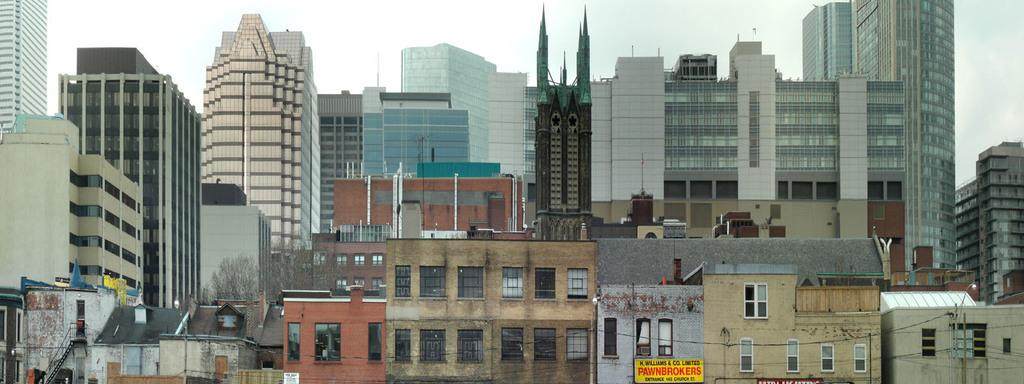What type of structures are present in the image? There are buildings and towers in the image. What else can be seen in the image besides structures? There are trees, poles with wires, boards, and stairs in the image. What is visible at the top of the image? The sky is visible at the top of the image. What type of bear can be seen climbing the stairs in the image? There is no bear present in the image, and therefore no such activity can be observed. What is the income of the person who owns the buildings in the image? The income of the person who owns the buildings cannot be determined from the image. 